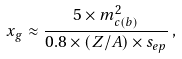Convert formula to latex. <formula><loc_0><loc_0><loc_500><loc_500>x _ { g } \approx \frac { 5 \times m _ { c ( b ) } ^ { 2 } } { 0 . 8 \times ( Z / A ) \times s _ { e p } } \, ,</formula> 